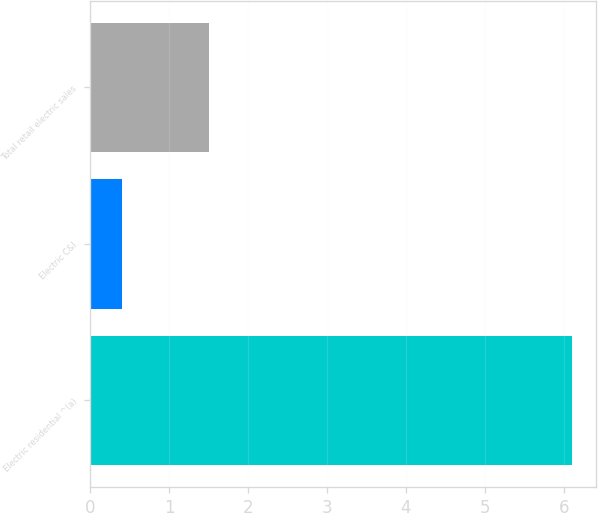Convert chart to OTSL. <chart><loc_0><loc_0><loc_500><loc_500><bar_chart><fcel>Electric residential ^(a)<fcel>Electric C&I<fcel>Total retail electric sales<nl><fcel>6.1<fcel>0.4<fcel>1.5<nl></chart> 